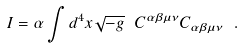Convert formula to latex. <formula><loc_0><loc_0><loc_500><loc_500>I = \alpha \int d ^ { 4 } x \sqrt { - g } \ C ^ { \alpha \beta \mu \nu } C _ { \alpha \beta \mu \nu } \ .</formula> 